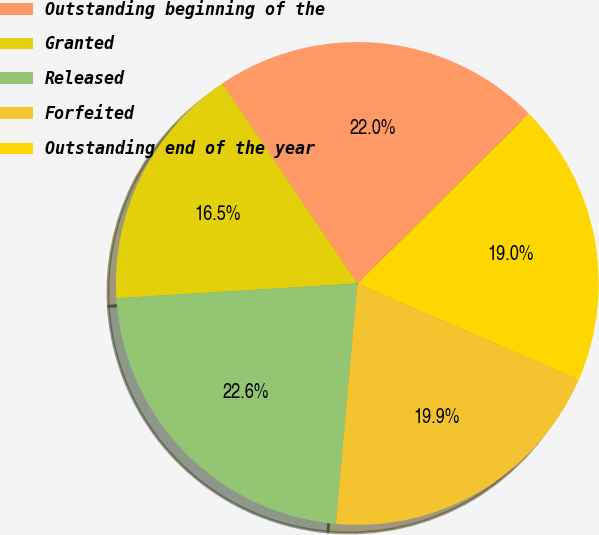Convert chart to OTSL. <chart><loc_0><loc_0><loc_500><loc_500><pie_chart><fcel>Outstanding beginning of the<fcel>Granted<fcel>Released<fcel>Forfeited<fcel>Outstanding end of the year<nl><fcel>22.03%<fcel>16.52%<fcel>22.61%<fcel>19.89%<fcel>18.95%<nl></chart> 